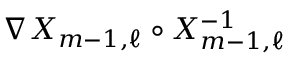Convert formula to latex. <formula><loc_0><loc_0><loc_500><loc_500>\nabla X _ { m - 1 , \ell } \circ X _ { m - 1 , \ell } ^ { - 1 }</formula> 